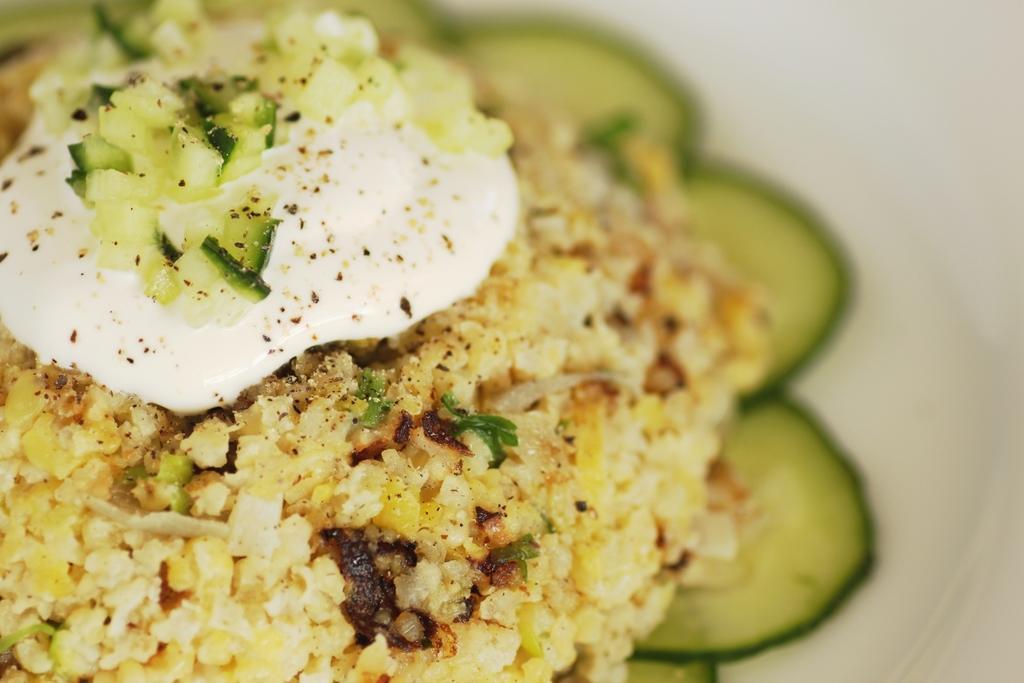Can you describe this image briefly? Here in this picture we can see some food item present on a plate. 